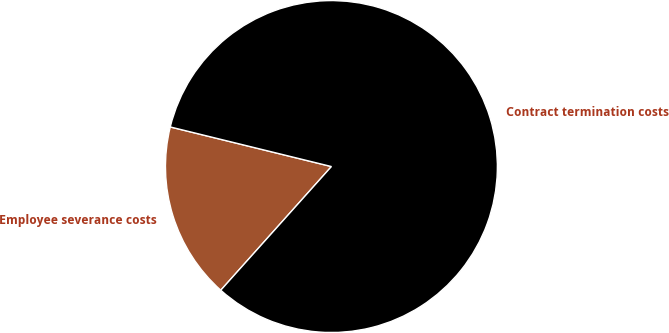Convert chart to OTSL. <chart><loc_0><loc_0><loc_500><loc_500><pie_chart><fcel>Employee severance costs<fcel>Contract termination costs<nl><fcel>17.22%<fcel>82.78%<nl></chart> 